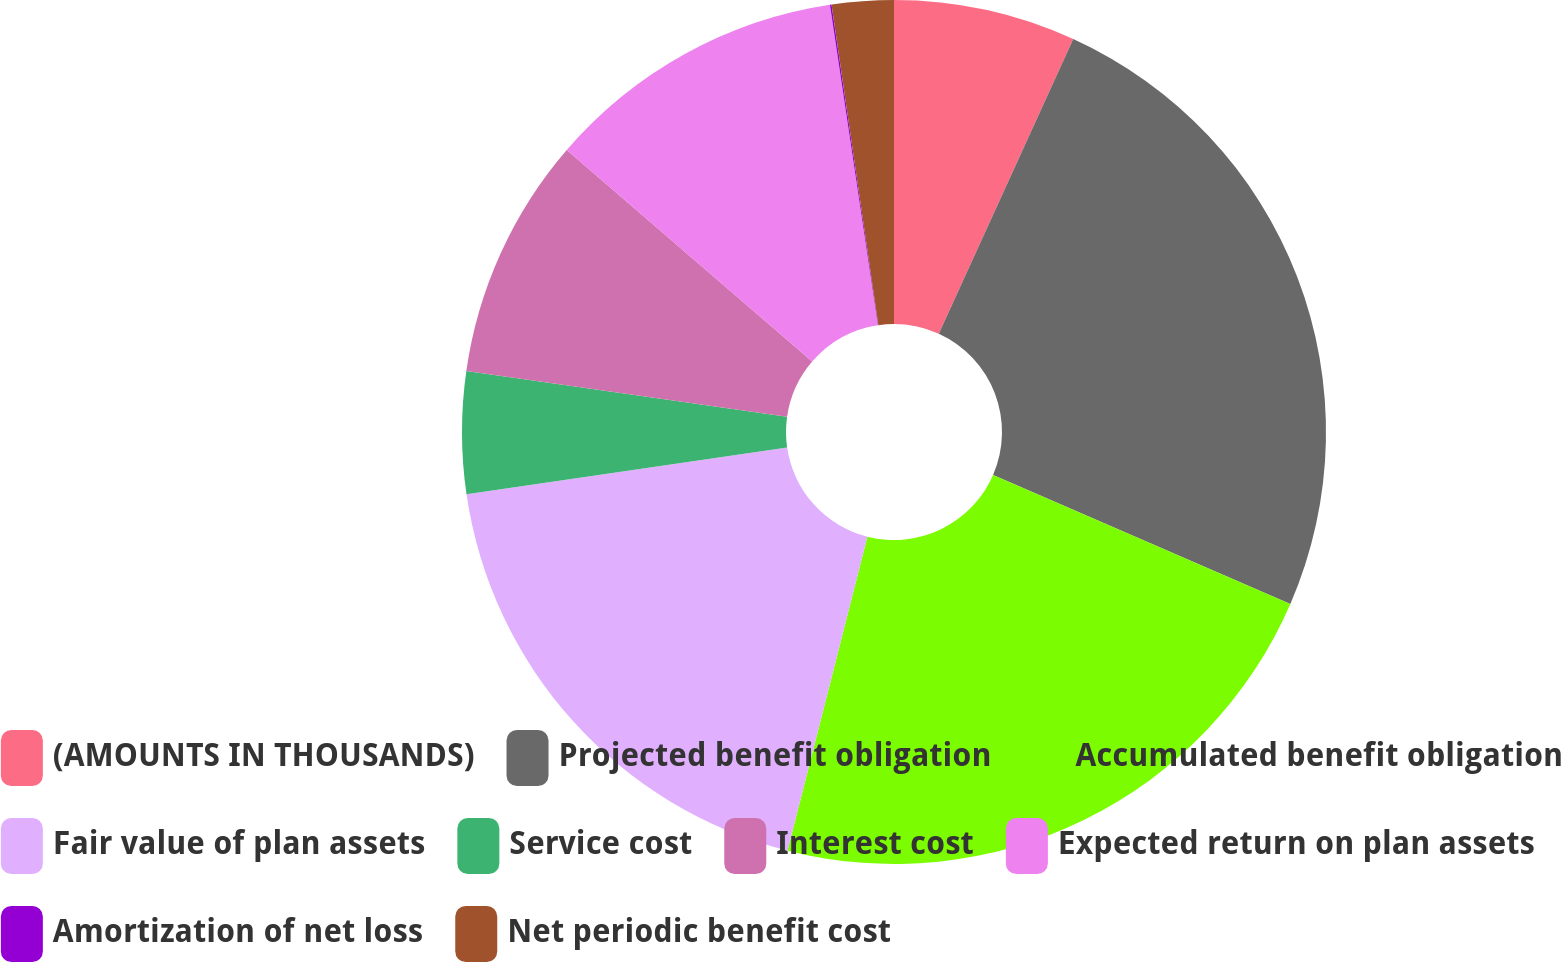Convert chart to OTSL. <chart><loc_0><loc_0><loc_500><loc_500><pie_chart><fcel>(AMOUNTS IN THOUSANDS)<fcel>Projected benefit obligation<fcel>Accumulated benefit obligation<fcel>Fair value of plan assets<fcel>Service cost<fcel>Interest cost<fcel>Expected return on plan assets<fcel>Amortization of net loss<fcel>Net periodic benefit cost<nl><fcel>6.81%<fcel>24.7%<fcel>22.45%<fcel>18.73%<fcel>4.56%<fcel>9.06%<fcel>11.31%<fcel>0.06%<fcel>2.31%<nl></chart> 